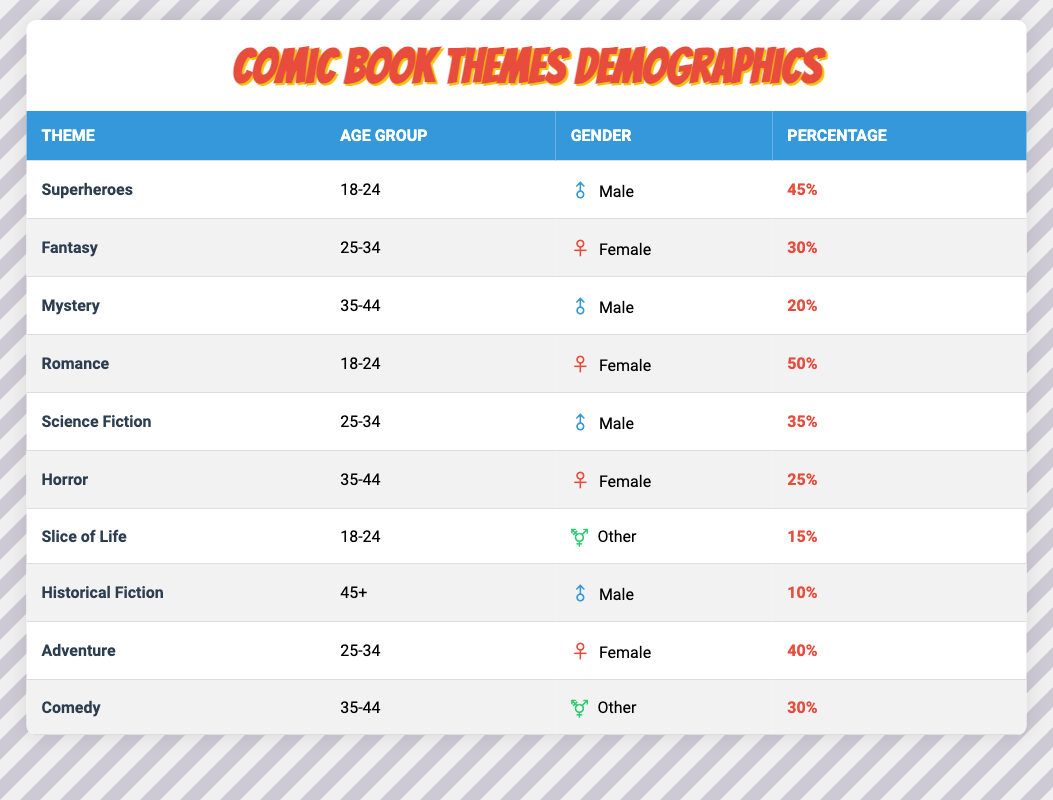What is the most popular comic book theme among the 18-24 age group? In the table, we see there are three themes listed under the 18-24 age group: Superheroes (45%), Romance (50%), and Slice of Life (15%). Romance has the highest percentage at 50%, making it the most popular theme in this age group.
Answer: Romance Which theme is most popular among males aged 35-44? In the table, the theme listed for males aged 35-44 is Mystery (20%). Therefore, it is the only theme in that demographic, and hence it is the most popular theme for this group.
Answer: Mystery What percentage of the demographic for Horror is female? The table shows that the Horror theme is associated with females aged 35-44, and the percentage is listed as 25%. Therefore, 25% of the demographic for Horror is female.
Answer: 25% Which age group has the highest percentage for Adventure? Looking at the Adventure theme, it is listed under the 25-34 age group with a percentage of 40%. This is the highest percentage for any theme for that age group, making it notable.
Answer: 25-34 Is the percentage of females in Romance higher than in Superheroes? In the table, Romance has 50% females (age group 18-24), while Superheroes have 45% males (age group 18-24). Since the percentage of females is higher in Romance, the answer is yes.
Answer: Yes What themes fall under the age group of 25-34? The themes that correspond to the age group 25-34 in the table are Fantasy (30%), Science Fiction (35%), and Adventure (40%). Therefore, those are the themes that fall under this age group.
Answer: Fantasy, Science Fiction, Adventure What is the average percentage for female readers across all themes? The table lists percentages for female readers in Romance (50%), Fantasy (30%), Horror (25%), and Adventure (40%). To find the average, we sum these percentages: 50 + 30 + 25 + 40 = 145. Then we divide by 4 (as there are 4 entries): 145/4 = 36.25.
Answer: 36.25 Which gender is statistically less represented based on the percentages for Historical Fiction? Historical Fiction is listed as having a percentage of 10% for males aged 45+. There are no other entries for Historical Fiction that involve other genders or age groups, indicating that this theme has low representation overall for males.
Answer: Male What are the themes that have a percentage greater than 30%? The themes with a percentage greater than 30% are Superheroes (45%), Romance (50%), Science Fiction (35%), Adventure (40%), and Comedy (30%). Tallying these gives us a total of five themes over the 30% mark.
Answer: Superheroes, Romance, Science Fiction, Adventure, Comedy Is there a theme associated with readers aged 45 and older? Yes, the table indicates that Historical Fiction is the only theme specifically linked with the 45+ age group.
Answer: Yes 